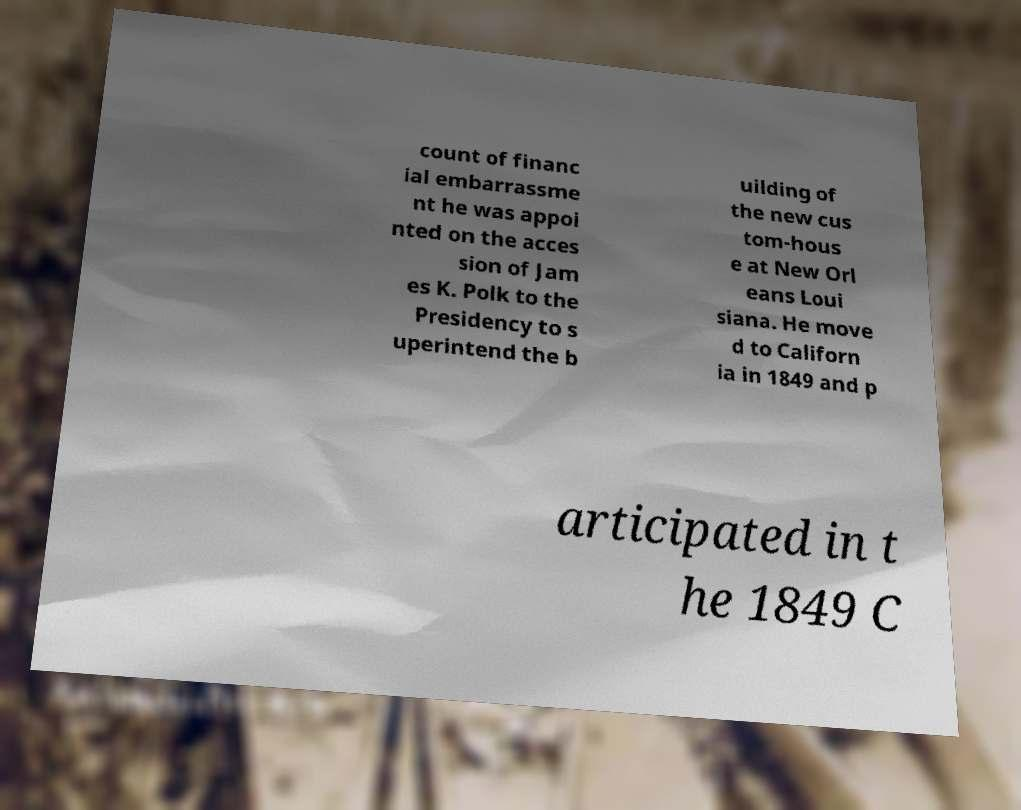There's text embedded in this image that I need extracted. Can you transcribe it verbatim? count of financ ial embarrassme nt he was appoi nted on the acces sion of Jam es K. Polk to the Presidency to s uperintend the b uilding of the new cus tom-hous e at New Orl eans Loui siana. He move d to Californ ia in 1849 and p articipated in t he 1849 C 